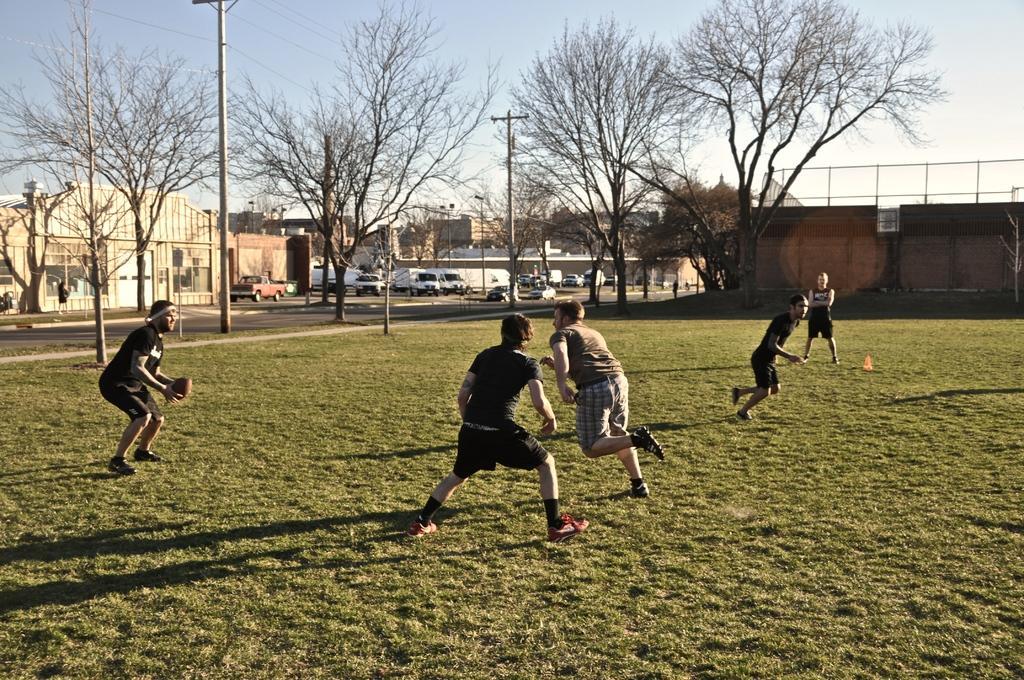Please provide a concise description of this image. In this image there are few men who are running on the ground. In the background there are houses. There are electric poles around the ground. In the background there is a wall. At the top there is the sky. There are vehicles on the road. 